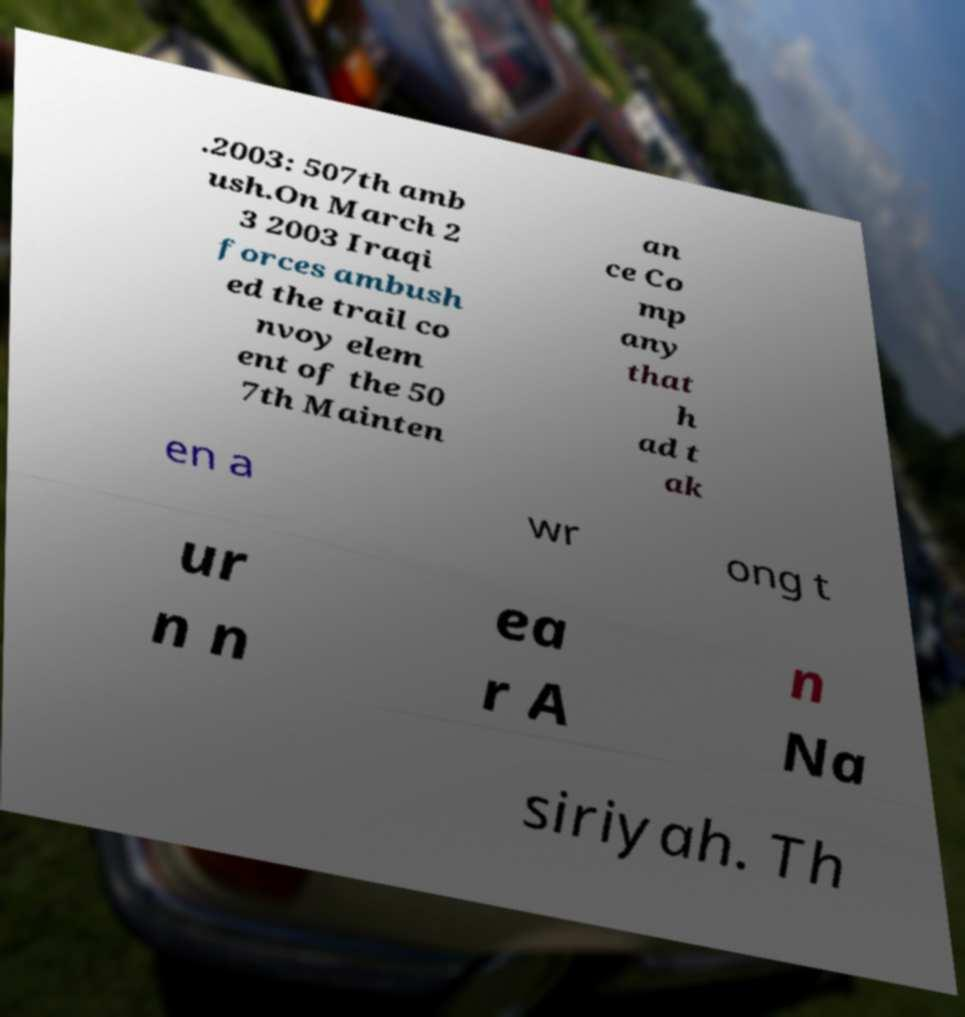Can you read and provide the text displayed in the image?This photo seems to have some interesting text. Can you extract and type it out for me? .2003: 507th amb ush.On March 2 3 2003 Iraqi forces ambush ed the trail co nvoy elem ent of the 50 7th Mainten an ce Co mp any that h ad t ak en a wr ong t ur n n ea r A n Na siriyah. Th 